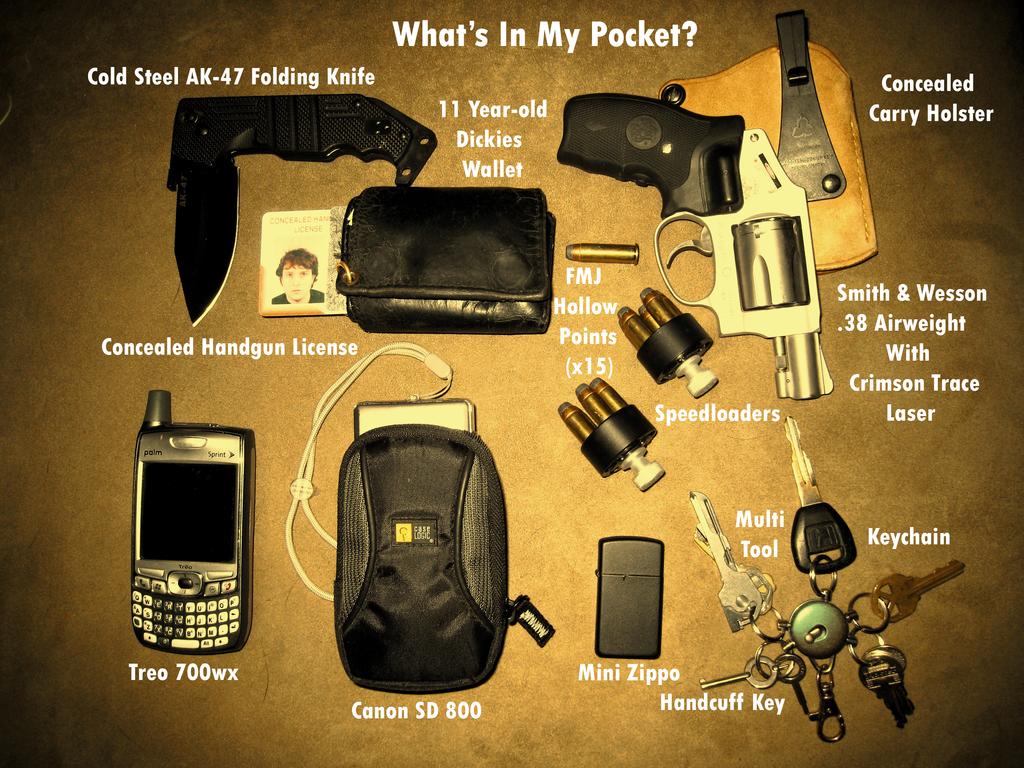What is the name of the phone?
Your response must be concise. Treo 700wx. What type of camera is this?
Give a very brief answer. Canon sd 800. 